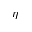<formula> <loc_0><loc_0><loc_500><loc_500>\eta</formula> 